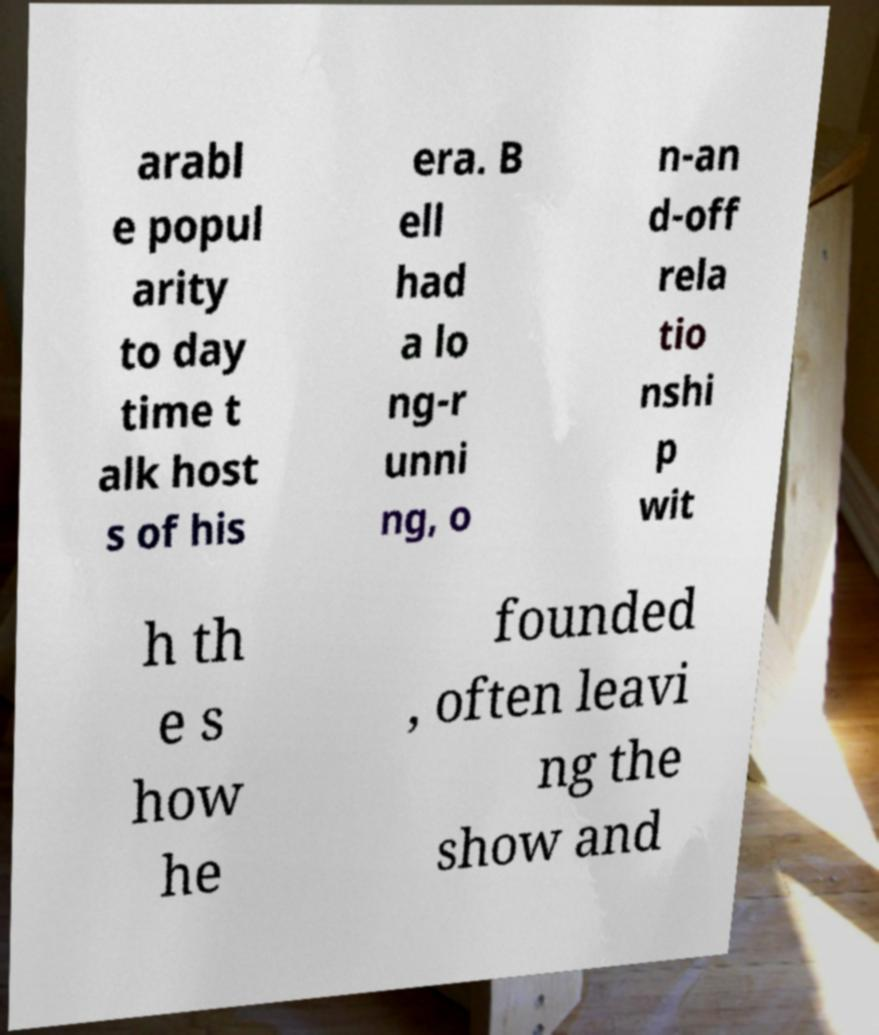Can you read and provide the text displayed in the image?This photo seems to have some interesting text. Can you extract and type it out for me? arabl e popul arity to day time t alk host s of his era. B ell had a lo ng-r unni ng, o n-an d-off rela tio nshi p wit h th e s how he founded , often leavi ng the show and 